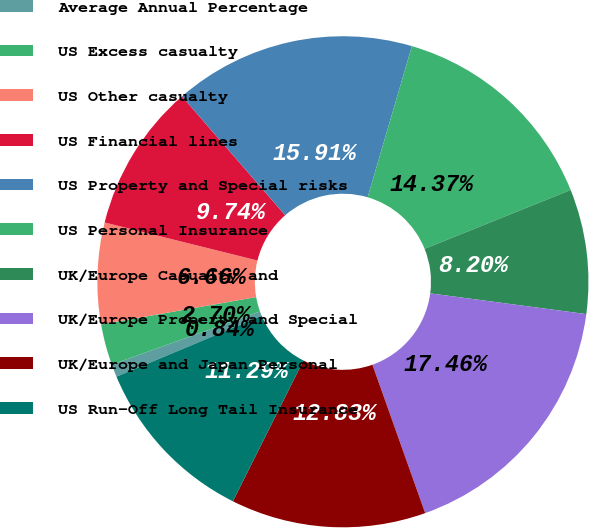<chart> <loc_0><loc_0><loc_500><loc_500><pie_chart><fcel>Average Annual Percentage<fcel>US Excess casualty<fcel>US Other casualty<fcel>US Financial lines<fcel>US Property and Special risks<fcel>US Personal Insurance<fcel>UK/Europe Casualty and<fcel>UK/Europe Property and Special<fcel>UK/Europe and Japan Personal<fcel>US Run-Off Long Tail Insurance<nl><fcel>0.84%<fcel>2.7%<fcel>6.66%<fcel>9.74%<fcel>15.91%<fcel>14.37%<fcel>8.2%<fcel>17.46%<fcel>12.83%<fcel>11.29%<nl></chart> 